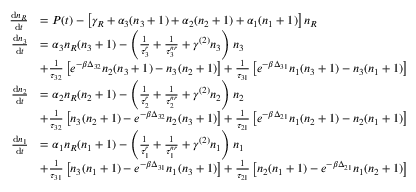Convert formula to latex. <formula><loc_0><loc_0><loc_500><loc_500>\begin{array} { r l } { \frac { d n _ { R } } { d t } } & { = P ( t ) - \left [ \gamma _ { R } + \alpha _ { 3 } ( n _ { 3 } + 1 ) + \alpha _ { 2 } ( n _ { 2 } + 1 ) + \alpha _ { 1 } ( n _ { 1 } + 1 ) \right ] n _ { R } } \\ { \frac { d n _ { 3 } } { d t } } & { = \alpha _ { 3 } n _ { R } ( n _ { 3 } + 1 ) - \left ( \frac { 1 } { \tau _ { 3 } ^ { r } } + \frac { 1 } { \tau _ { 3 } ^ { n r } } + \gamma ^ { ( 2 ) } n _ { 3 } \right ) n _ { 3 } } \\ & { + \frac { 1 } { \tau _ { 3 2 } } \left [ e ^ { - \beta \Delta _ { 3 2 } } n _ { 2 } ( n _ { 3 } + 1 ) - n _ { 3 } ( n _ { 2 } + 1 ) \right ] + \frac { 1 } { \tau _ { 3 1 } } \left [ e ^ { - \beta \Delta _ { 3 1 } } n _ { 1 } ( n _ { 3 } + 1 ) - n _ { 3 } ( n _ { 1 } + 1 ) \right ] } \\ { \frac { d n _ { 2 } } { d t } } & { = \alpha _ { 2 } n _ { R } ( n _ { 2 } + 1 ) - \left ( \frac { 1 } { \tau _ { 2 } ^ { r } } + \frac { 1 } { \tau _ { 2 } ^ { n r } } + \gamma ^ { ( 2 ) } n _ { 2 } \right ) n _ { 2 } } \\ & { + \frac { 1 } { \tau _ { 3 2 } } \left [ n _ { 3 } ( n _ { 2 } + 1 ) - e ^ { - \beta \Delta _ { 3 2 } } n _ { 2 } ( n _ { 3 } + 1 ) \right ] + \frac { 1 } { \tau _ { 2 1 } } \left [ e ^ { - \beta \Delta _ { 2 1 } } n _ { 1 } ( n _ { 2 } + 1 ) - n _ { 2 } ( n _ { 1 } + 1 ) \right ] } \\ { \frac { d n _ { 1 } } { d t } } & { = \alpha _ { 1 } n _ { R } ( n _ { 1 } + 1 ) - \left ( \frac { 1 } { \tau _ { 1 } ^ { r } } + \frac { 1 } { \tau _ { 1 } ^ { n r } } + \gamma ^ { ( 2 ) } n _ { 1 } \right ) n _ { 1 } } \\ & { + \frac { 1 } { \tau _ { 3 1 } } \left [ n _ { 3 } ( n _ { 1 } + 1 ) - e ^ { - \beta \Delta _ { 3 1 } } n _ { 1 } ( n _ { 3 } + 1 ) \right ] + \frac { 1 } { \tau _ { 2 1 } } \left [ n _ { 2 } ( n _ { 1 } + 1 ) - e ^ { - \beta \Delta _ { 2 1 } } n _ { 1 } ( n _ { 2 } + 1 ) \right ] } \end{array}</formula> 